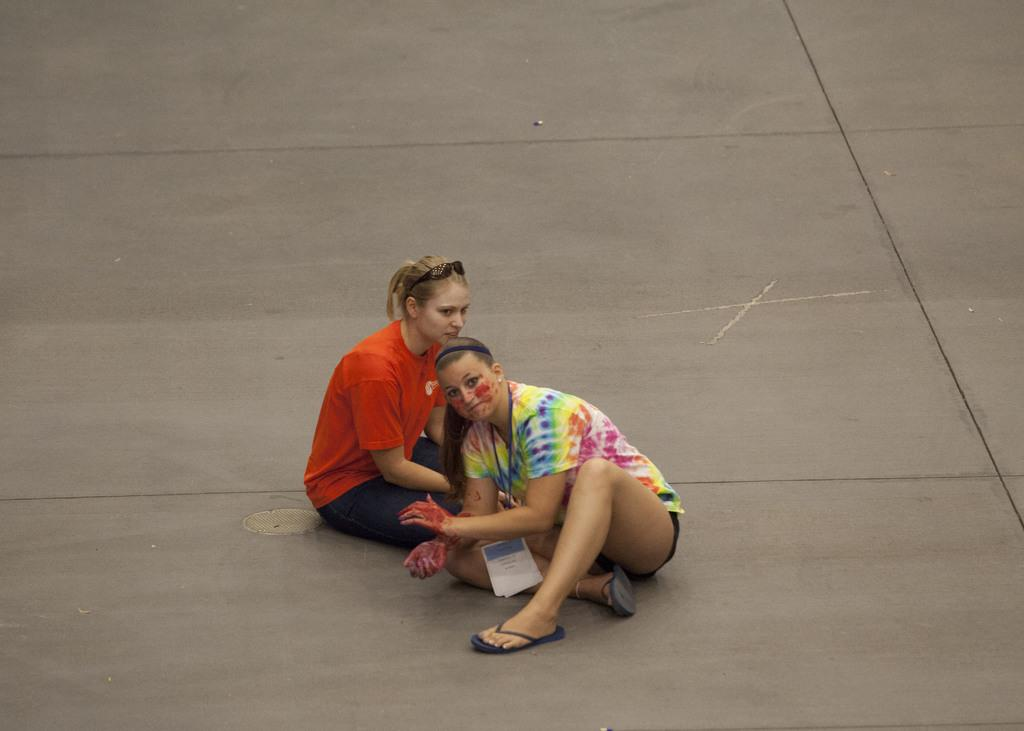How many people are sitting on the ground in the image? There are two persons sitting on the ground in the image. Can you describe one of the persons? One of the persons is a woman. What is the woman wearing on her upper body? The woman is wearing an orange t-shirt. What accessory is the woman wearing on her face? The woman is wearing black color glasses. What type of company is depicted in the image? There is no company depicted in the image; it features two persons sitting on the ground. How many fingers can be seen on the woman's hand in the image? The image does not show the woman's hand, so it is not possible to determine the number of fingers. 